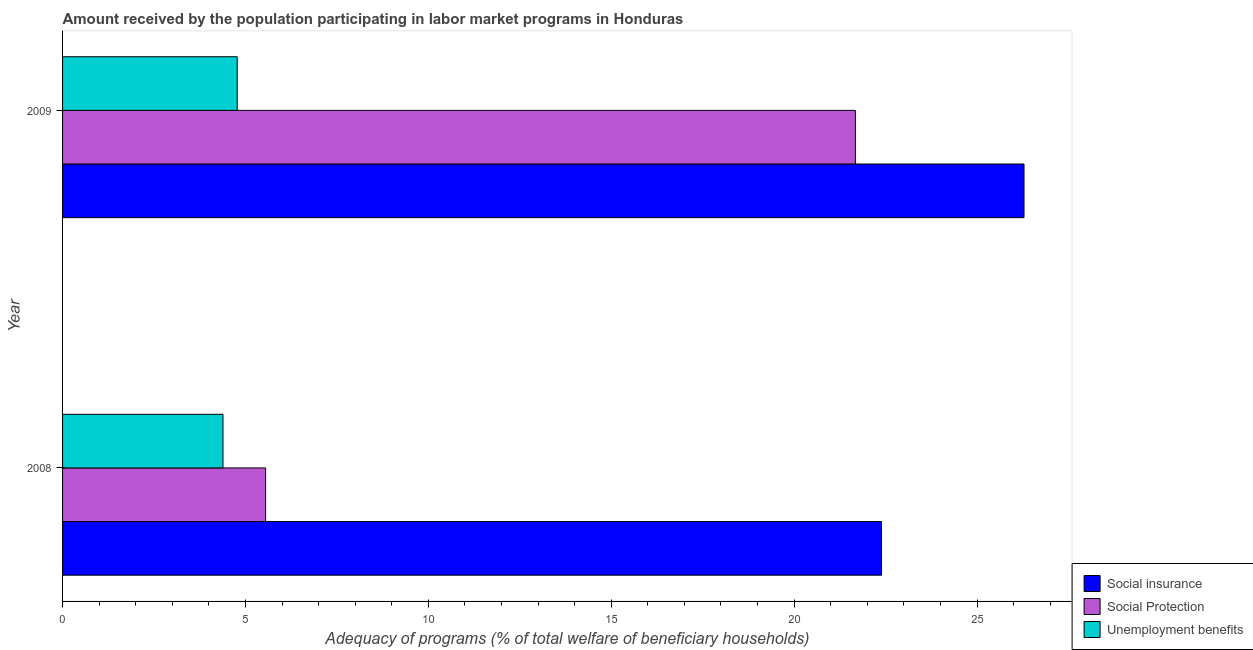How many different coloured bars are there?
Keep it short and to the point. 3. How many groups of bars are there?
Provide a short and direct response. 2. Are the number of bars on each tick of the Y-axis equal?
Your answer should be compact. Yes. How many bars are there on the 2nd tick from the top?
Ensure brevity in your answer.  3. How many bars are there on the 2nd tick from the bottom?
Your answer should be compact. 3. What is the amount received by the population participating in social insurance programs in 2008?
Your answer should be compact. 22.39. Across all years, what is the maximum amount received by the population participating in social protection programs?
Make the answer very short. 21.67. Across all years, what is the minimum amount received by the population participating in social protection programs?
Make the answer very short. 5.55. In which year was the amount received by the population participating in social protection programs minimum?
Provide a succinct answer. 2008. What is the total amount received by the population participating in social protection programs in the graph?
Offer a terse response. 27.22. What is the difference between the amount received by the population participating in social insurance programs in 2008 and that in 2009?
Make the answer very short. -3.9. What is the difference between the amount received by the population participating in social insurance programs in 2009 and the amount received by the population participating in unemployment benefits programs in 2008?
Your answer should be compact. 21.9. What is the average amount received by the population participating in social insurance programs per year?
Give a very brief answer. 24.34. In the year 2009, what is the difference between the amount received by the population participating in social protection programs and amount received by the population participating in social insurance programs?
Provide a succinct answer. -4.61. What is the ratio of the amount received by the population participating in social insurance programs in 2008 to that in 2009?
Offer a very short reply. 0.85. Is the amount received by the population participating in social protection programs in 2008 less than that in 2009?
Offer a terse response. Yes. Is the difference between the amount received by the population participating in social protection programs in 2008 and 2009 greater than the difference between the amount received by the population participating in unemployment benefits programs in 2008 and 2009?
Provide a succinct answer. No. In how many years, is the amount received by the population participating in unemployment benefits programs greater than the average amount received by the population participating in unemployment benefits programs taken over all years?
Offer a terse response. 1. What does the 1st bar from the top in 2008 represents?
Make the answer very short. Unemployment benefits. What does the 2nd bar from the bottom in 2008 represents?
Your response must be concise. Social Protection. Is it the case that in every year, the sum of the amount received by the population participating in social insurance programs and amount received by the population participating in social protection programs is greater than the amount received by the population participating in unemployment benefits programs?
Provide a short and direct response. Yes. Are the values on the major ticks of X-axis written in scientific E-notation?
Make the answer very short. No. Does the graph contain grids?
Give a very brief answer. No. Where does the legend appear in the graph?
Your response must be concise. Bottom right. How are the legend labels stacked?
Provide a succinct answer. Vertical. What is the title of the graph?
Make the answer very short. Amount received by the population participating in labor market programs in Honduras. Does "Coal sources" appear as one of the legend labels in the graph?
Give a very brief answer. No. What is the label or title of the X-axis?
Provide a succinct answer. Adequacy of programs (% of total welfare of beneficiary households). What is the Adequacy of programs (% of total welfare of beneficiary households) of Social insurance in 2008?
Offer a very short reply. 22.39. What is the Adequacy of programs (% of total welfare of beneficiary households) of Social Protection in 2008?
Make the answer very short. 5.55. What is the Adequacy of programs (% of total welfare of beneficiary households) in Unemployment benefits in 2008?
Give a very brief answer. 4.39. What is the Adequacy of programs (% of total welfare of beneficiary households) of Social insurance in 2009?
Provide a short and direct response. 26.28. What is the Adequacy of programs (% of total welfare of beneficiary households) of Social Protection in 2009?
Your answer should be very brief. 21.67. What is the Adequacy of programs (% of total welfare of beneficiary households) of Unemployment benefits in 2009?
Your response must be concise. 4.77. Across all years, what is the maximum Adequacy of programs (% of total welfare of beneficiary households) in Social insurance?
Give a very brief answer. 26.28. Across all years, what is the maximum Adequacy of programs (% of total welfare of beneficiary households) of Social Protection?
Provide a short and direct response. 21.67. Across all years, what is the maximum Adequacy of programs (% of total welfare of beneficiary households) of Unemployment benefits?
Provide a succinct answer. 4.77. Across all years, what is the minimum Adequacy of programs (% of total welfare of beneficiary households) of Social insurance?
Provide a short and direct response. 22.39. Across all years, what is the minimum Adequacy of programs (% of total welfare of beneficiary households) of Social Protection?
Offer a terse response. 5.55. Across all years, what is the minimum Adequacy of programs (% of total welfare of beneficiary households) of Unemployment benefits?
Ensure brevity in your answer.  4.39. What is the total Adequacy of programs (% of total welfare of beneficiary households) in Social insurance in the graph?
Ensure brevity in your answer.  48.67. What is the total Adequacy of programs (% of total welfare of beneficiary households) of Social Protection in the graph?
Ensure brevity in your answer.  27.22. What is the total Adequacy of programs (% of total welfare of beneficiary households) in Unemployment benefits in the graph?
Ensure brevity in your answer.  9.16. What is the difference between the Adequacy of programs (% of total welfare of beneficiary households) in Social insurance in 2008 and that in 2009?
Provide a succinct answer. -3.9. What is the difference between the Adequacy of programs (% of total welfare of beneficiary households) of Social Protection in 2008 and that in 2009?
Offer a very short reply. -16.12. What is the difference between the Adequacy of programs (% of total welfare of beneficiary households) in Unemployment benefits in 2008 and that in 2009?
Your response must be concise. -0.39. What is the difference between the Adequacy of programs (% of total welfare of beneficiary households) of Social insurance in 2008 and the Adequacy of programs (% of total welfare of beneficiary households) of Social Protection in 2009?
Offer a very short reply. 0.71. What is the difference between the Adequacy of programs (% of total welfare of beneficiary households) of Social insurance in 2008 and the Adequacy of programs (% of total welfare of beneficiary households) of Unemployment benefits in 2009?
Give a very brief answer. 17.61. What is the difference between the Adequacy of programs (% of total welfare of beneficiary households) in Social Protection in 2008 and the Adequacy of programs (% of total welfare of beneficiary households) in Unemployment benefits in 2009?
Your answer should be compact. 0.78. What is the average Adequacy of programs (% of total welfare of beneficiary households) in Social insurance per year?
Provide a short and direct response. 24.34. What is the average Adequacy of programs (% of total welfare of beneficiary households) in Social Protection per year?
Provide a succinct answer. 13.61. What is the average Adequacy of programs (% of total welfare of beneficiary households) of Unemployment benefits per year?
Keep it short and to the point. 4.58. In the year 2008, what is the difference between the Adequacy of programs (% of total welfare of beneficiary households) of Social insurance and Adequacy of programs (% of total welfare of beneficiary households) of Social Protection?
Provide a short and direct response. 16.84. In the year 2008, what is the difference between the Adequacy of programs (% of total welfare of beneficiary households) in Social insurance and Adequacy of programs (% of total welfare of beneficiary households) in Unemployment benefits?
Your answer should be very brief. 18. In the year 2008, what is the difference between the Adequacy of programs (% of total welfare of beneficiary households) in Social Protection and Adequacy of programs (% of total welfare of beneficiary households) in Unemployment benefits?
Make the answer very short. 1.17. In the year 2009, what is the difference between the Adequacy of programs (% of total welfare of beneficiary households) of Social insurance and Adequacy of programs (% of total welfare of beneficiary households) of Social Protection?
Your answer should be compact. 4.61. In the year 2009, what is the difference between the Adequacy of programs (% of total welfare of beneficiary households) in Social insurance and Adequacy of programs (% of total welfare of beneficiary households) in Unemployment benefits?
Make the answer very short. 21.51. In the year 2009, what is the difference between the Adequacy of programs (% of total welfare of beneficiary households) of Social Protection and Adequacy of programs (% of total welfare of beneficiary households) of Unemployment benefits?
Provide a short and direct response. 16.9. What is the ratio of the Adequacy of programs (% of total welfare of beneficiary households) of Social insurance in 2008 to that in 2009?
Your response must be concise. 0.85. What is the ratio of the Adequacy of programs (% of total welfare of beneficiary households) in Social Protection in 2008 to that in 2009?
Offer a terse response. 0.26. What is the ratio of the Adequacy of programs (% of total welfare of beneficiary households) in Unemployment benefits in 2008 to that in 2009?
Provide a succinct answer. 0.92. What is the difference between the highest and the second highest Adequacy of programs (% of total welfare of beneficiary households) in Social insurance?
Provide a short and direct response. 3.9. What is the difference between the highest and the second highest Adequacy of programs (% of total welfare of beneficiary households) in Social Protection?
Ensure brevity in your answer.  16.12. What is the difference between the highest and the second highest Adequacy of programs (% of total welfare of beneficiary households) of Unemployment benefits?
Ensure brevity in your answer.  0.39. What is the difference between the highest and the lowest Adequacy of programs (% of total welfare of beneficiary households) of Social insurance?
Offer a terse response. 3.9. What is the difference between the highest and the lowest Adequacy of programs (% of total welfare of beneficiary households) of Social Protection?
Provide a succinct answer. 16.12. What is the difference between the highest and the lowest Adequacy of programs (% of total welfare of beneficiary households) in Unemployment benefits?
Your answer should be very brief. 0.39. 